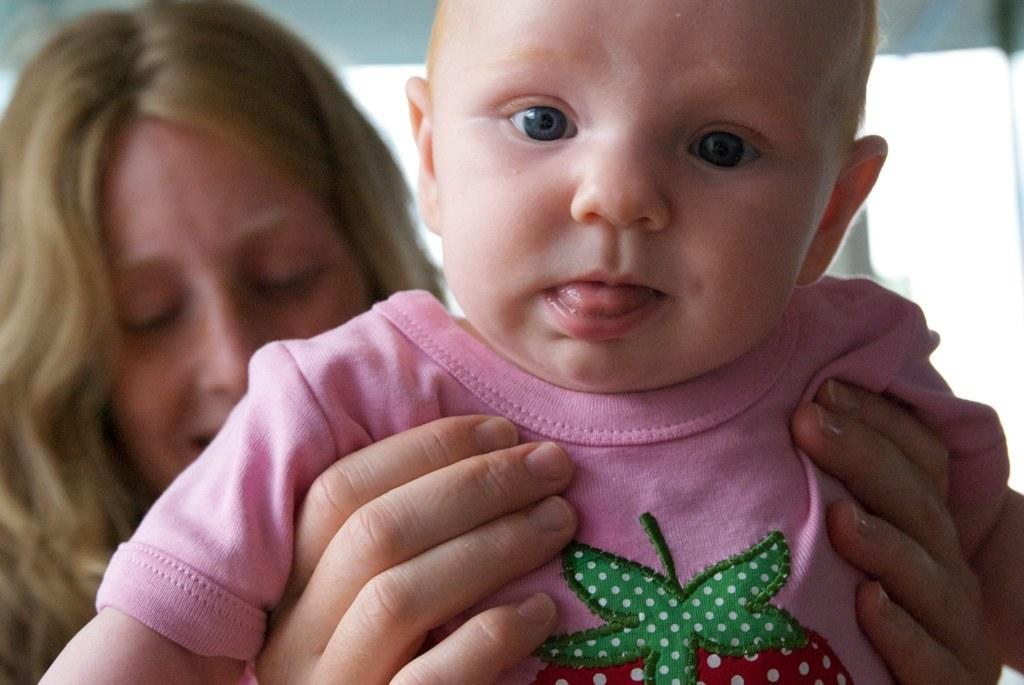In one or two sentences, can you explain what this image depicts? In this image there is a child towards the bottom of the image, there is a woman towards the left of the image, the woman is carrying a child, there is a wall towards the top of the image, the background of the image is white in color. 